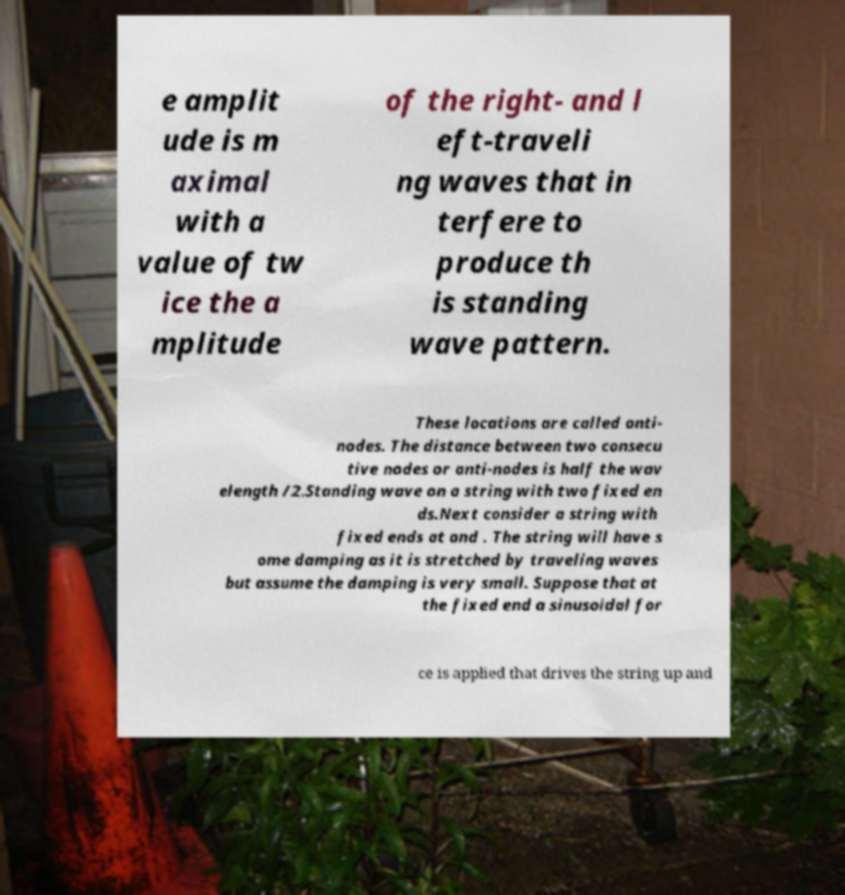There's text embedded in this image that I need extracted. Can you transcribe it verbatim? e amplit ude is m aximal with a value of tw ice the a mplitude of the right- and l eft-traveli ng waves that in terfere to produce th is standing wave pattern. These locations are called anti- nodes. The distance between two consecu tive nodes or anti-nodes is half the wav elength /2.Standing wave on a string with two fixed en ds.Next consider a string with fixed ends at and . The string will have s ome damping as it is stretched by traveling waves but assume the damping is very small. Suppose that at the fixed end a sinusoidal for ce is applied that drives the string up and 